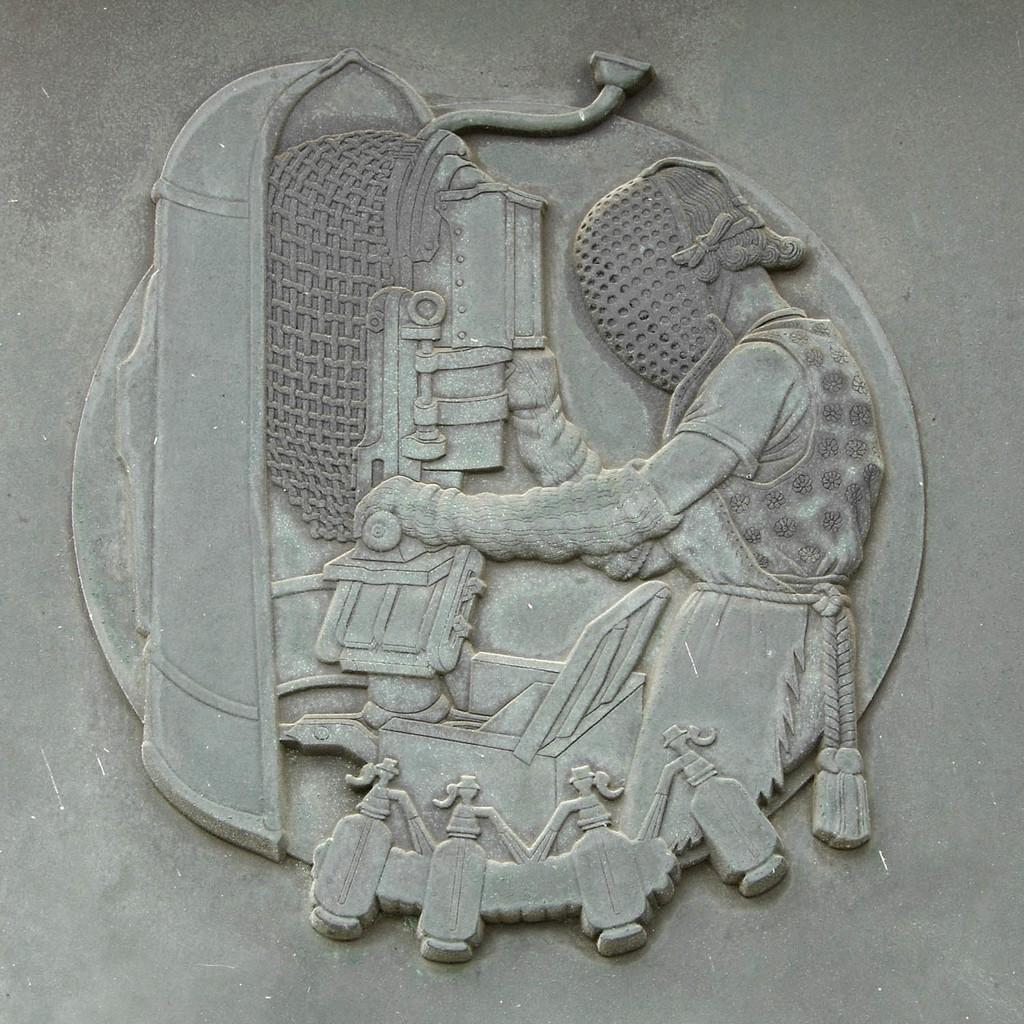What type of art or sculpture is depicted in the image? There is a stone carving in the image. Can you describe the material used for the carving? The carving is made of stone. What type of shade is provided by the stone carving in the image? The stone carving does not provide any shade in the image, as it is a sculpture and not a structure with a roof or covering. 